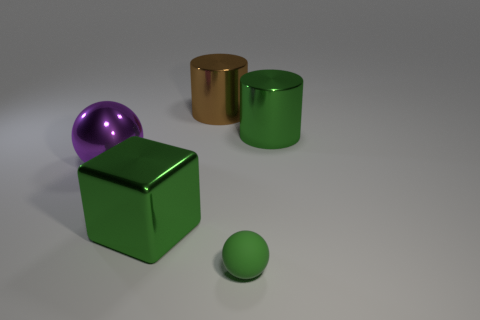What textures can be identified on the objects in the image? The objects in the image display a variety of textures. The large brown cylinder has a reflective, likely metallic texture. The green cube and green cylinder have a matte, smoother surface, suggesting a non-metallic material such as painted wood or plastic. The small green sphere, in contrast, has a glossy finish, which is indicative of a smooth, possibly plastic material. The purple sphere has a reflective surface similar to the brown cylinder, hinting at a metallic or glass-like material. 